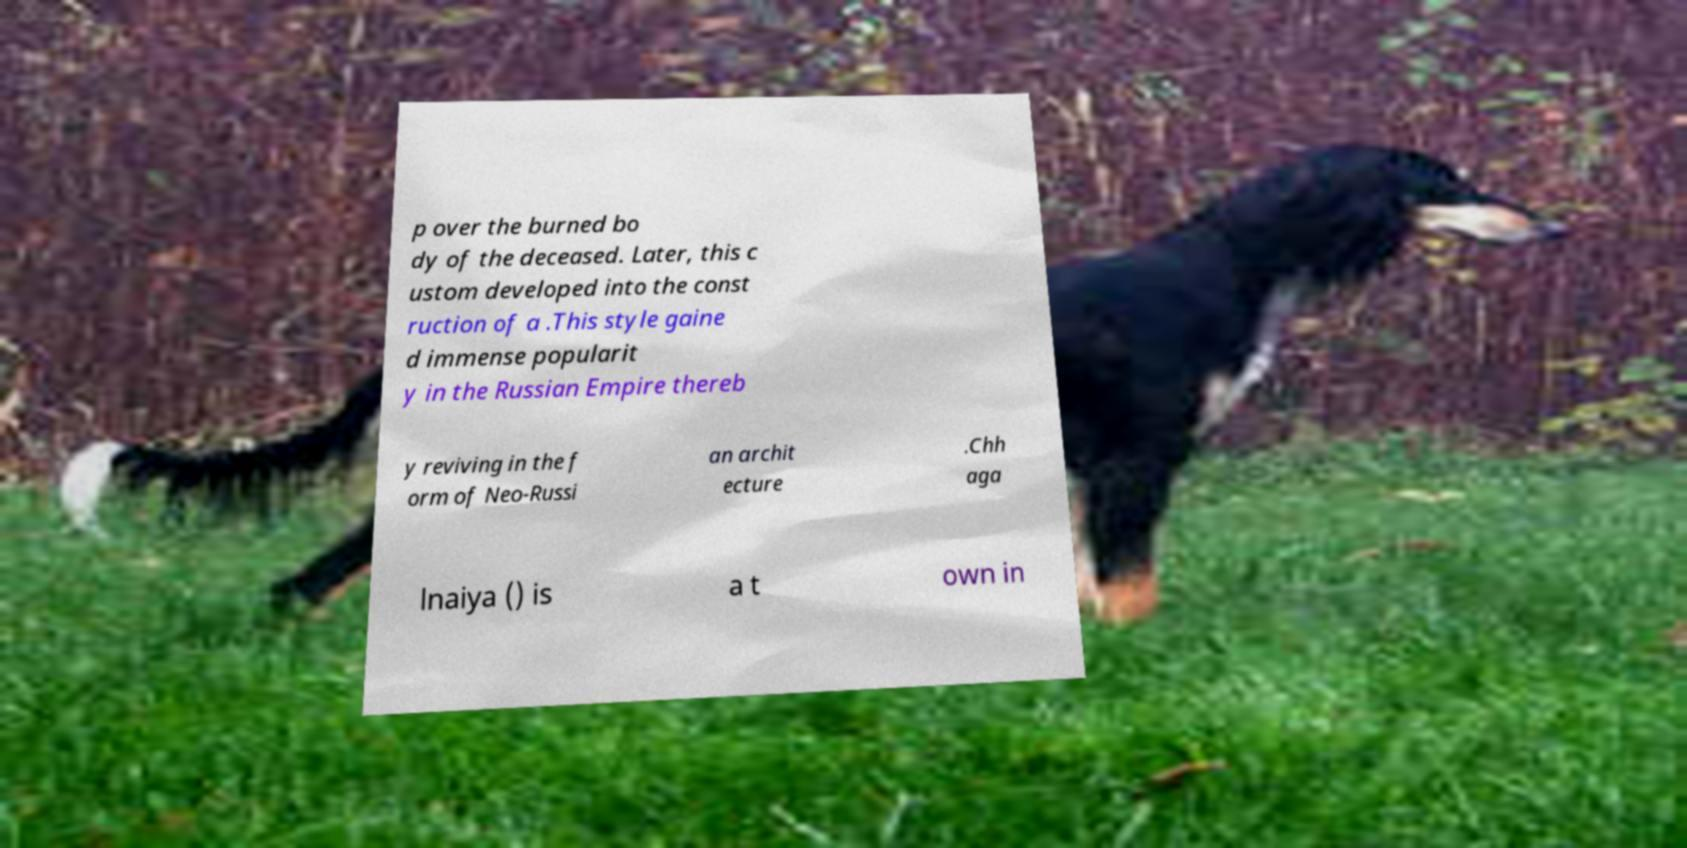What messages or text are displayed in this image? I need them in a readable, typed format. p over the burned bo dy of the deceased. Later, this c ustom developed into the const ruction of a .This style gaine d immense popularit y in the Russian Empire thereb y reviving in the f orm of Neo-Russi an archit ecture .Chh aga lnaiya () is a t own in 